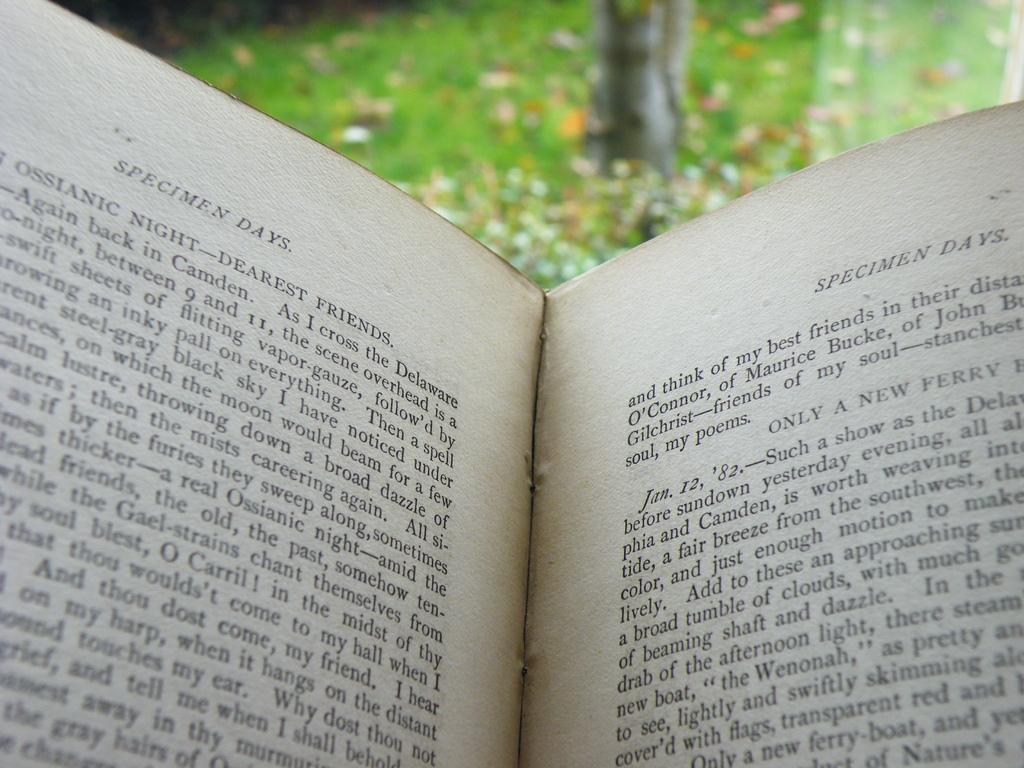<image>
Provide a brief description of the given image. A book called "Specimen Days" is opened up. 